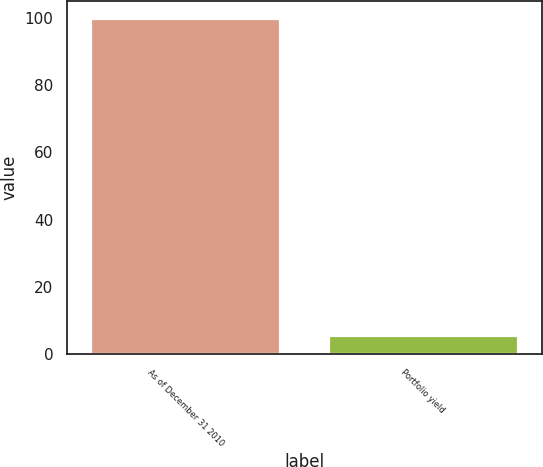Convert chart to OTSL. <chart><loc_0><loc_0><loc_500><loc_500><bar_chart><fcel>As of December 31 2010<fcel>Portfolio yield<nl><fcel>100<fcel>5.63<nl></chart> 